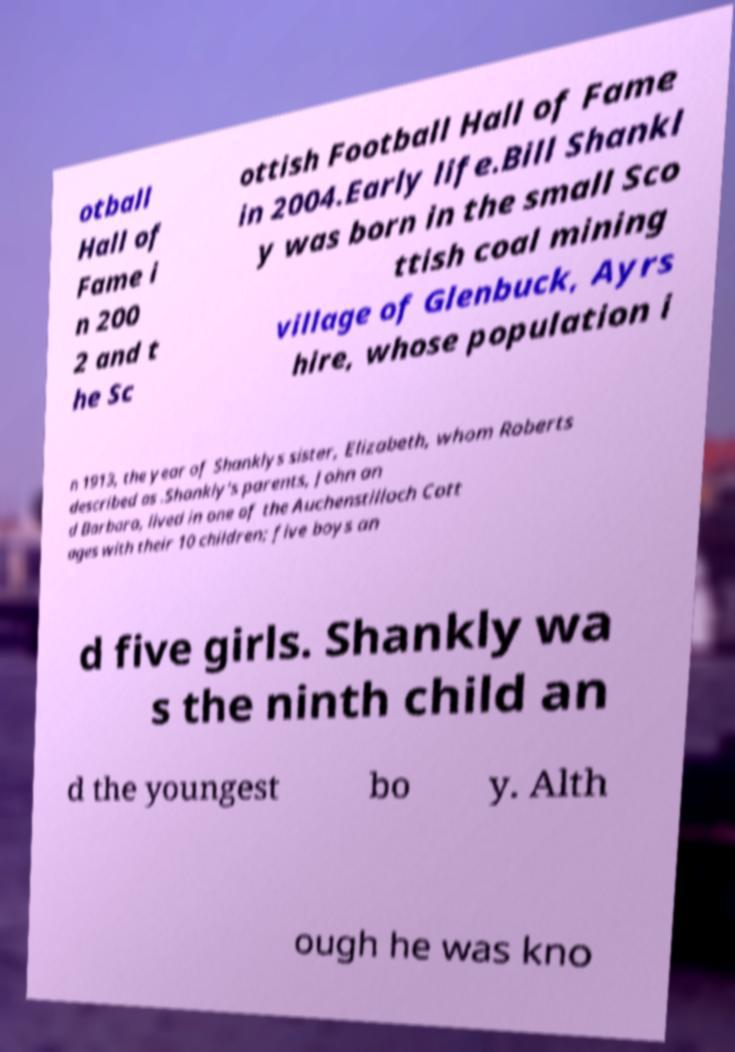Please identify and transcribe the text found in this image. otball Hall of Fame i n 200 2 and t he Sc ottish Football Hall of Fame in 2004.Early life.Bill Shankl y was born in the small Sco ttish coal mining village of Glenbuck, Ayrs hire, whose population i n 1913, the year of Shanklys sister, Elizabeth, whom Roberts described as .Shankly's parents, John an d Barbara, lived in one of the Auchenstilloch Cott ages with their 10 children; five boys an d five girls. Shankly wa s the ninth child an d the youngest bo y. Alth ough he was kno 